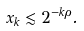<formula> <loc_0><loc_0><loc_500><loc_500>x _ { k } \lesssim 2 ^ { - k \rho } .</formula> 